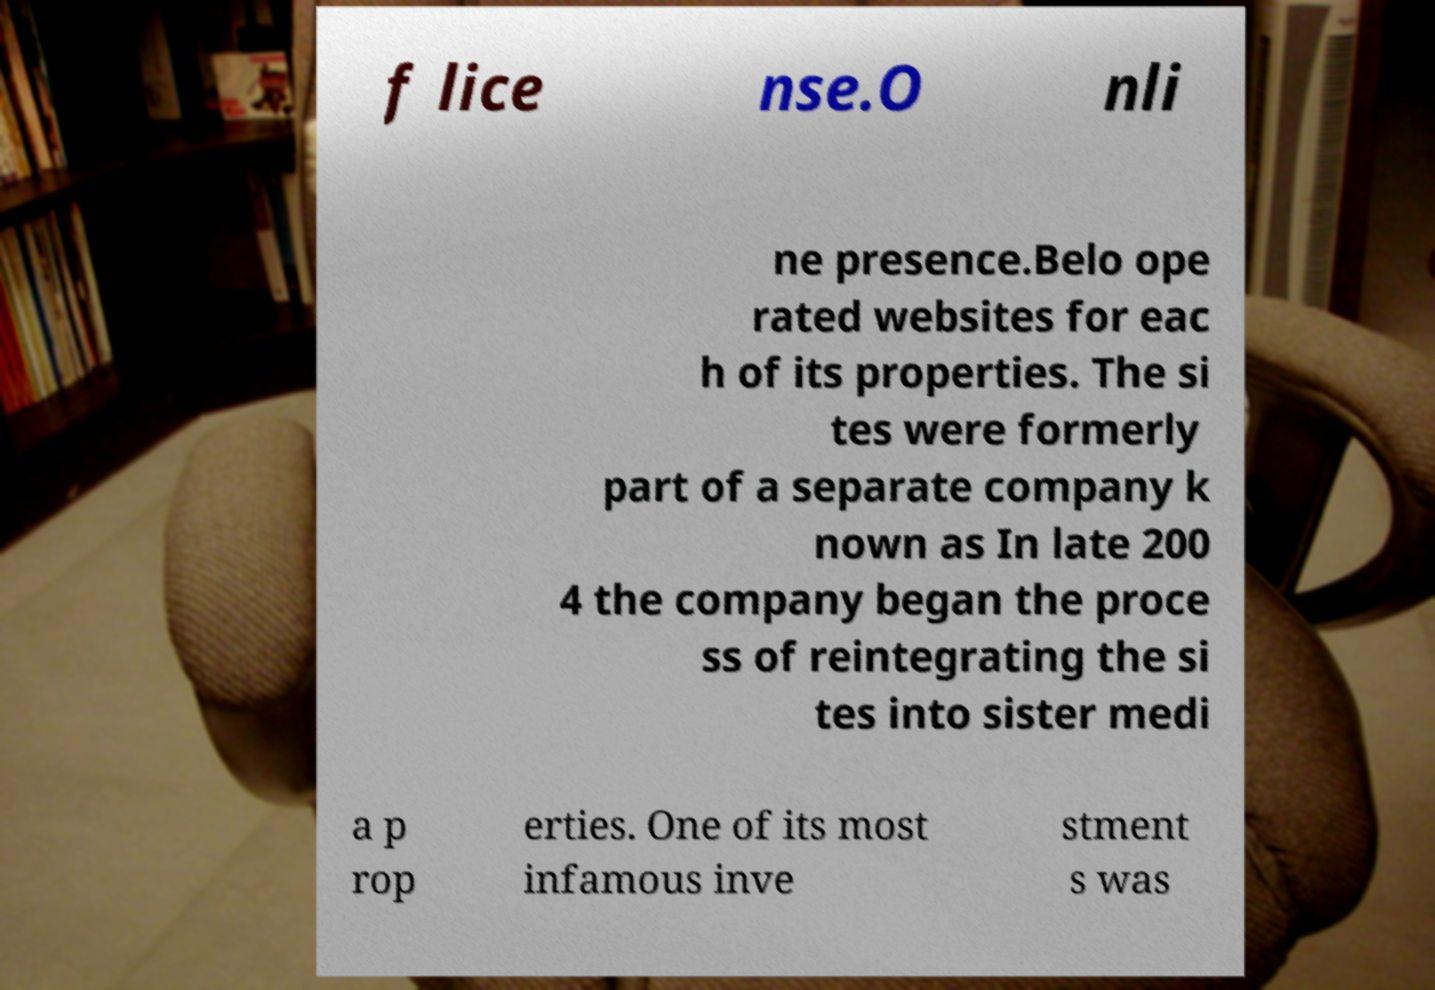Can you read and provide the text displayed in the image?This photo seems to have some interesting text. Can you extract and type it out for me? f lice nse.O nli ne presence.Belo ope rated websites for eac h of its properties. The si tes were formerly part of a separate company k nown as In late 200 4 the company began the proce ss of reintegrating the si tes into sister medi a p rop erties. One of its most infamous inve stment s was 